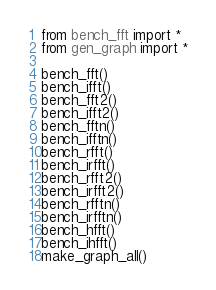<code> <loc_0><loc_0><loc_500><loc_500><_Python_>from bench_fft import *
from gen_graph import *

bench_fft()
bench_ifft()
bench_fft2()
bench_ifft2()
bench_fftn()
bench_ifftn()
bench_rfft()
bench_irfft()
bench_rfft2()
bench_irfft2()
bench_rfftn()
bench_irfftn()
bench_hfft()
bench_ihfft()
make_graph_all()

</code> 